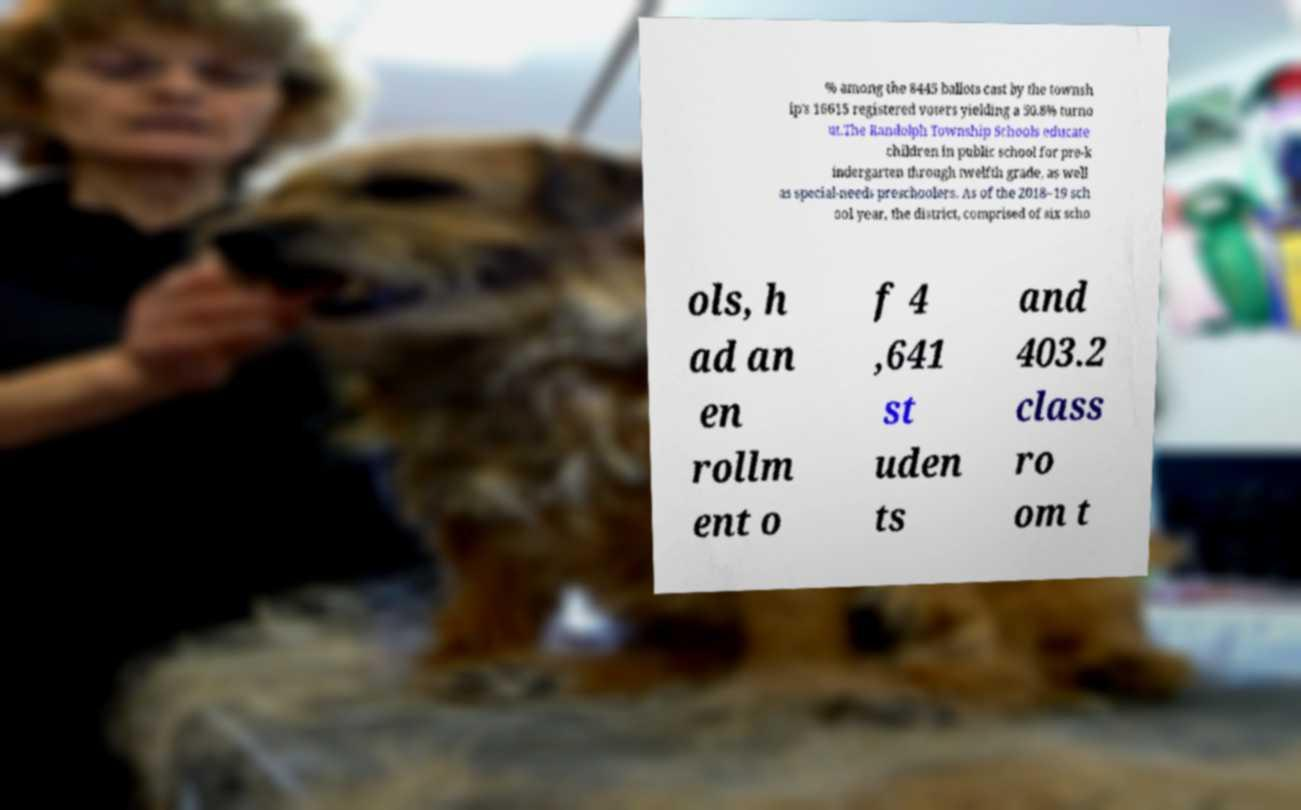There's text embedded in this image that I need extracted. Can you transcribe it verbatim? % among the 8445 ballots cast by the townsh ip's 16615 registered voters yielding a 50.8% turno ut.The Randolph Township Schools educate children in public school for pre-k indergarten through twelfth grade, as well as special-needs preschoolers. As of the 2018–19 sch ool year, the district, comprised of six scho ols, h ad an en rollm ent o f 4 ,641 st uden ts and 403.2 class ro om t 